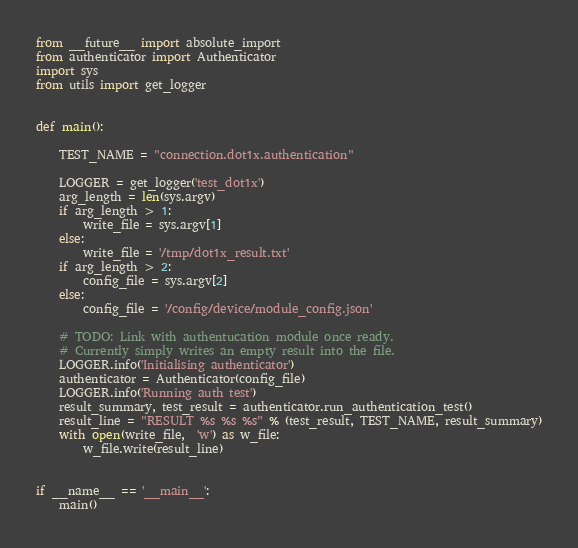<code> <loc_0><loc_0><loc_500><loc_500><_Python_>from __future__ import absolute_import
from authenticator import Authenticator
import sys
from utils import get_logger


def main():

    TEST_NAME = "connection.dot1x.authentication"

    LOGGER = get_logger('test_dot1x')
    arg_length = len(sys.argv)
    if arg_length > 1:
        write_file = sys.argv[1]
    else:
        write_file = '/tmp/dot1x_result.txt'
    if arg_length > 2:
        config_file = sys.argv[2]
    else:
        config_file = '/config/device/module_config.json'

    # TODO: Link with authentucation module once ready.
    # Currently simply writes an empty result into the file.
    LOGGER.info('Initialising authenticator')
    authenticator = Authenticator(config_file)
    LOGGER.info('Running auth test')
    result_summary, test_result = authenticator.run_authentication_test()
    result_line = "RESULT %s %s %s" % (test_result, TEST_NAME, result_summary)
    with open(write_file,  'w') as w_file:
        w_file.write(result_line)


if __name__ == '__main__':
    main()
</code> 